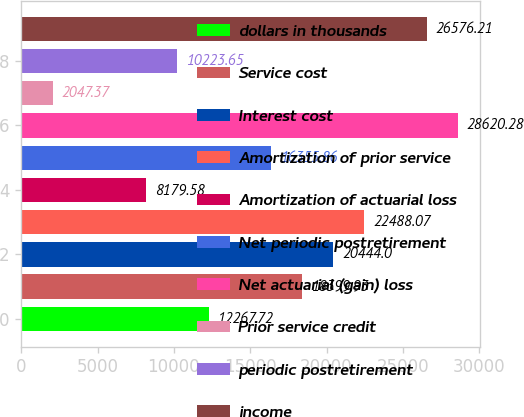Convert chart. <chart><loc_0><loc_0><loc_500><loc_500><bar_chart><fcel>dollars in thousands<fcel>Service cost<fcel>Interest cost<fcel>Amortization of prior service<fcel>Amortization of actuarial loss<fcel>Net periodic postretirement<fcel>Net actuarial (gain) loss<fcel>Prior service credit<fcel>periodic postretirement<fcel>income<nl><fcel>12267.7<fcel>18399.9<fcel>20444<fcel>22488.1<fcel>8179.58<fcel>16355.9<fcel>28620.3<fcel>2047.37<fcel>10223.6<fcel>26576.2<nl></chart> 